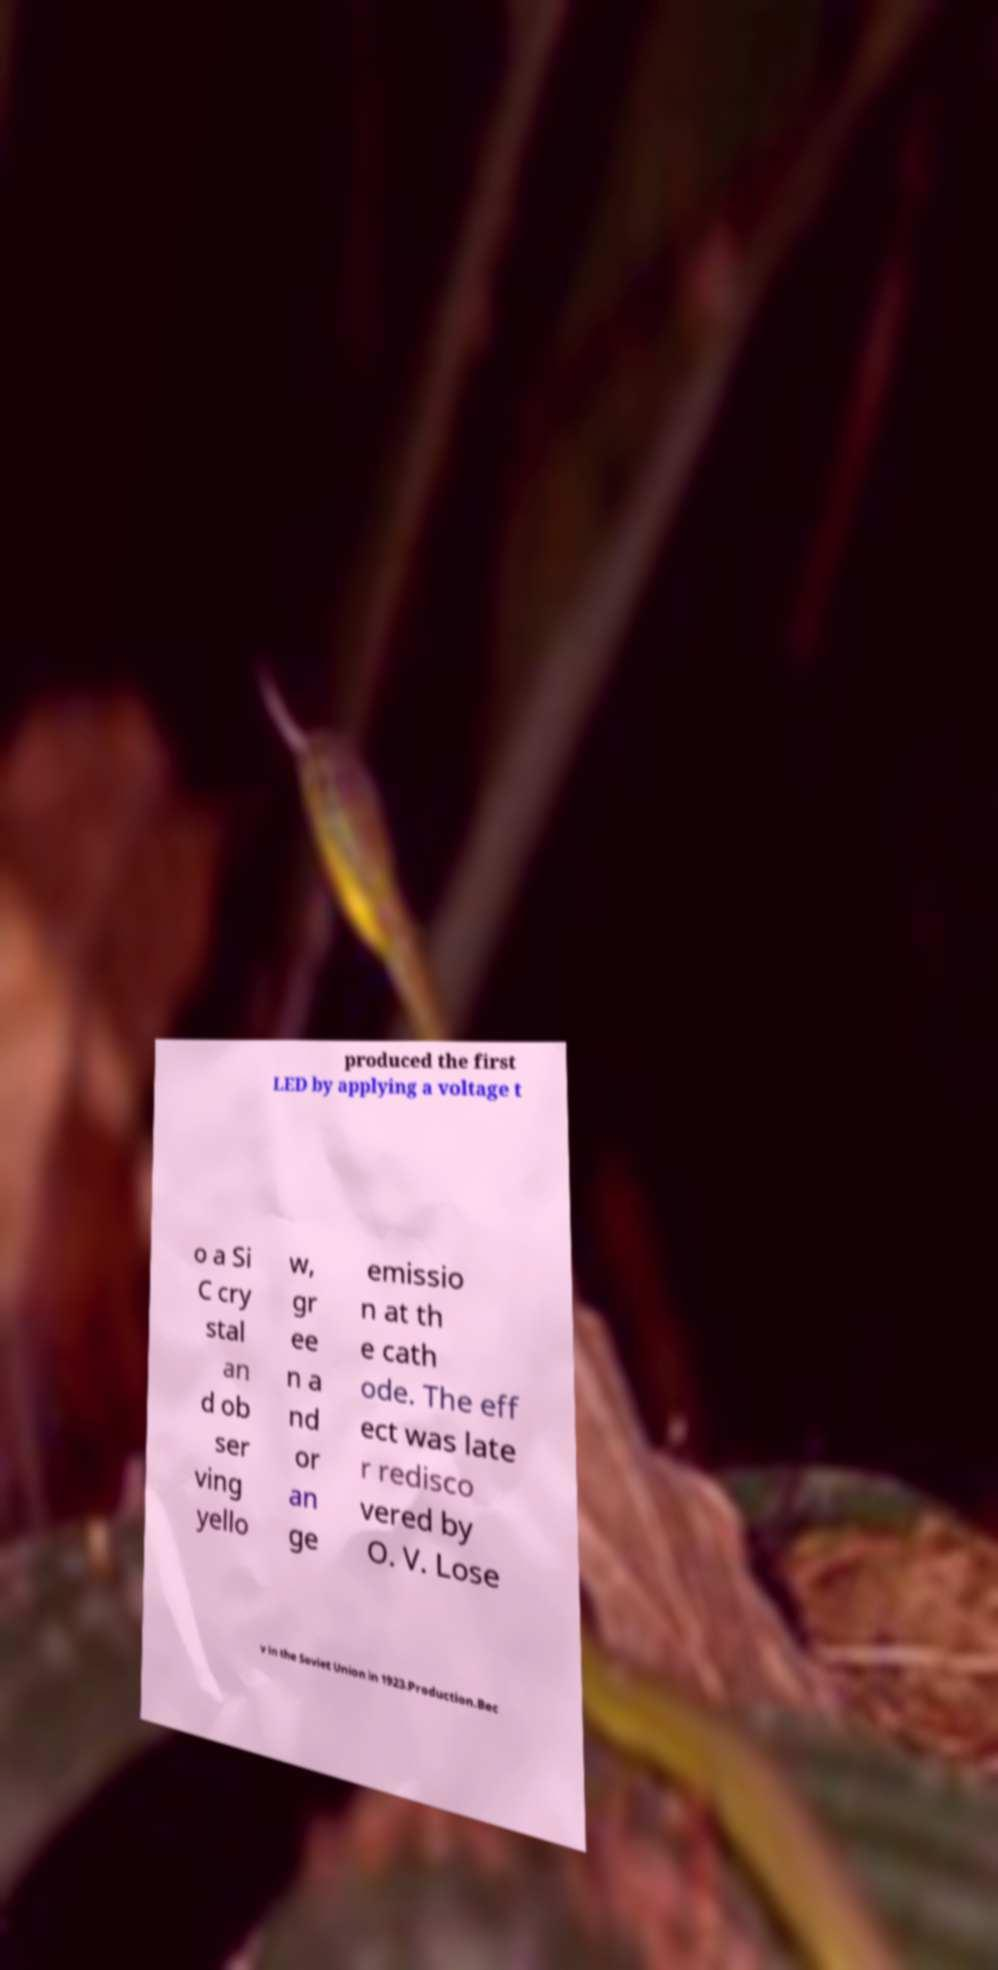Please identify and transcribe the text found in this image. produced the first LED by applying a voltage t o a Si C cry stal an d ob ser ving yello w, gr ee n a nd or an ge emissio n at th e cath ode. The eff ect was late r redisco vered by O. V. Lose v in the Soviet Union in 1923.Production.Bec 